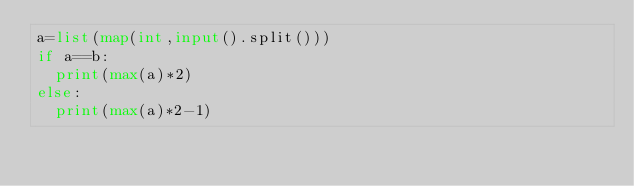<code> <loc_0><loc_0><loc_500><loc_500><_Python_>a=list(map(int,input().split()))
if a==b:
  print(max(a)*2)
else:
  print(max(a)*2-1)</code> 